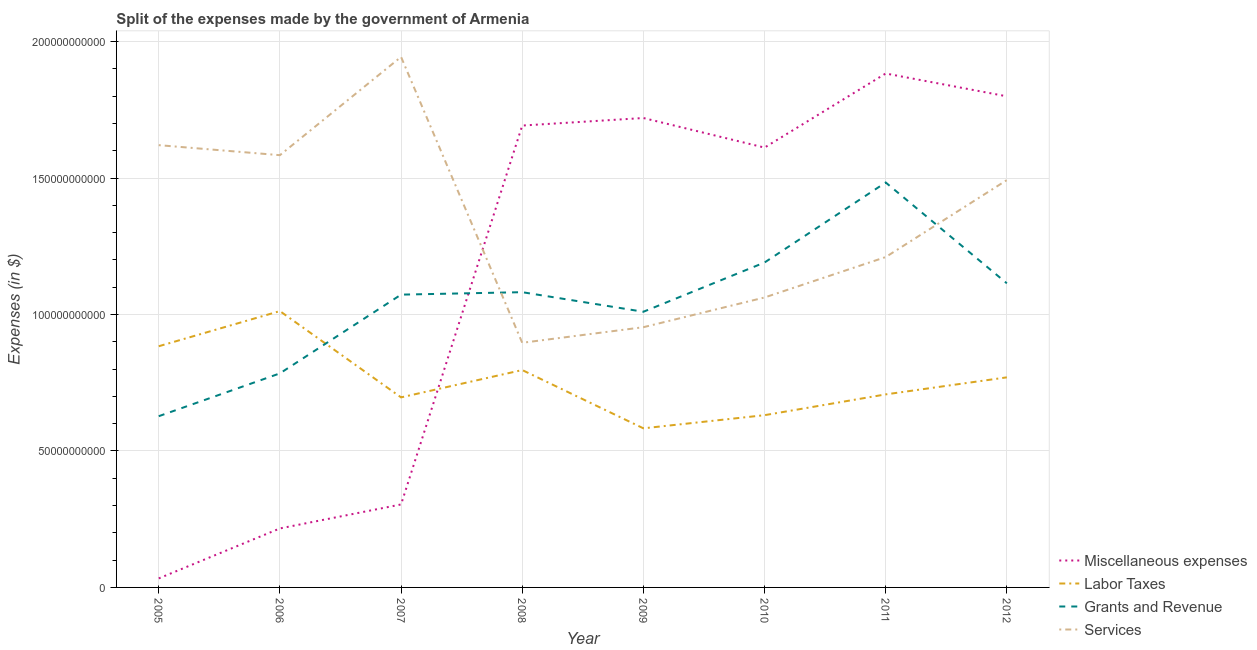How many different coloured lines are there?
Offer a very short reply. 4. Does the line corresponding to amount spent on labor taxes intersect with the line corresponding to amount spent on grants and revenue?
Give a very brief answer. Yes. Is the number of lines equal to the number of legend labels?
Your answer should be very brief. Yes. What is the amount spent on miscellaneous expenses in 2009?
Provide a short and direct response. 1.72e+11. Across all years, what is the maximum amount spent on labor taxes?
Keep it short and to the point. 1.01e+11. Across all years, what is the minimum amount spent on miscellaneous expenses?
Your answer should be very brief. 3.30e+09. In which year was the amount spent on labor taxes maximum?
Provide a succinct answer. 2006. In which year was the amount spent on services minimum?
Give a very brief answer. 2008. What is the total amount spent on services in the graph?
Make the answer very short. 1.08e+12. What is the difference between the amount spent on grants and revenue in 2007 and that in 2009?
Your response must be concise. 6.28e+09. What is the difference between the amount spent on grants and revenue in 2012 and the amount spent on miscellaneous expenses in 2008?
Your response must be concise. -5.78e+1. What is the average amount spent on miscellaneous expenses per year?
Provide a short and direct response. 1.16e+11. In the year 2011, what is the difference between the amount spent on labor taxes and amount spent on services?
Offer a terse response. -5.03e+1. In how many years, is the amount spent on grants and revenue greater than 100000000000 $?
Your response must be concise. 6. What is the ratio of the amount spent on grants and revenue in 2005 to that in 2009?
Ensure brevity in your answer.  0.62. Is the difference between the amount spent on labor taxes in 2008 and 2012 greater than the difference between the amount spent on grants and revenue in 2008 and 2012?
Your answer should be compact. Yes. What is the difference between the highest and the second highest amount spent on labor taxes?
Provide a succinct answer. 1.29e+1. What is the difference between the highest and the lowest amount spent on labor taxes?
Give a very brief answer. 4.30e+1. Is the sum of the amount spent on grants and revenue in 2007 and 2009 greater than the maximum amount spent on labor taxes across all years?
Provide a succinct answer. Yes. Is it the case that in every year, the sum of the amount spent on miscellaneous expenses and amount spent on labor taxes is greater than the sum of amount spent on grants and revenue and amount spent on services?
Provide a succinct answer. No. Is it the case that in every year, the sum of the amount spent on miscellaneous expenses and amount spent on labor taxes is greater than the amount spent on grants and revenue?
Make the answer very short. No. Does the amount spent on labor taxes monotonically increase over the years?
Offer a terse response. No. Is the amount spent on miscellaneous expenses strictly greater than the amount spent on grants and revenue over the years?
Provide a short and direct response. No. How many lines are there?
Your answer should be compact. 4. What is the difference between two consecutive major ticks on the Y-axis?
Give a very brief answer. 5.00e+1. Does the graph contain any zero values?
Offer a terse response. No. Where does the legend appear in the graph?
Provide a succinct answer. Bottom right. How many legend labels are there?
Ensure brevity in your answer.  4. What is the title of the graph?
Your answer should be very brief. Split of the expenses made by the government of Armenia. What is the label or title of the X-axis?
Your answer should be compact. Year. What is the label or title of the Y-axis?
Provide a short and direct response. Expenses (in $). What is the Expenses (in $) of Miscellaneous expenses in 2005?
Your response must be concise. 3.30e+09. What is the Expenses (in $) in Labor Taxes in 2005?
Your answer should be very brief. 8.84e+1. What is the Expenses (in $) of Grants and Revenue in 2005?
Provide a short and direct response. 6.27e+1. What is the Expenses (in $) in Services in 2005?
Your answer should be very brief. 1.62e+11. What is the Expenses (in $) in Miscellaneous expenses in 2006?
Provide a succinct answer. 2.16e+1. What is the Expenses (in $) of Labor Taxes in 2006?
Keep it short and to the point. 1.01e+11. What is the Expenses (in $) of Grants and Revenue in 2006?
Give a very brief answer. 7.84e+1. What is the Expenses (in $) in Services in 2006?
Ensure brevity in your answer.  1.58e+11. What is the Expenses (in $) of Miscellaneous expenses in 2007?
Offer a very short reply. 3.04e+1. What is the Expenses (in $) of Labor Taxes in 2007?
Ensure brevity in your answer.  6.96e+1. What is the Expenses (in $) in Grants and Revenue in 2007?
Give a very brief answer. 1.07e+11. What is the Expenses (in $) of Services in 2007?
Offer a terse response. 1.94e+11. What is the Expenses (in $) in Miscellaneous expenses in 2008?
Offer a very short reply. 1.69e+11. What is the Expenses (in $) of Labor Taxes in 2008?
Give a very brief answer. 7.97e+1. What is the Expenses (in $) in Grants and Revenue in 2008?
Give a very brief answer. 1.08e+11. What is the Expenses (in $) in Services in 2008?
Provide a short and direct response. 8.96e+1. What is the Expenses (in $) in Miscellaneous expenses in 2009?
Provide a succinct answer. 1.72e+11. What is the Expenses (in $) of Labor Taxes in 2009?
Offer a terse response. 5.83e+1. What is the Expenses (in $) of Grants and Revenue in 2009?
Ensure brevity in your answer.  1.01e+11. What is the Expenses (in $) of Services in 2009?
Your answer should be compact. 9.53e+1. What is the Expenses (in $) of Miscellaneous expenses in 2010?
Make the answer very short. 1.61e+11. What is the Expenses (in $) in Labor Taxes in 2010?
Make the answer very short. 6.31e+1. What is the Expenses (in $) in Grants and Revenue in 2010?
Your response must be concise. 1.19e+11. What is the Expenses (in $) of Services in 2010?
Your answer should be compact. 1.06e+11. What is the Expenses (in $) of Miscellaneous expenses in 2011?
Your answer should be very brief. 1.88e+11. What is the Expenses (in $) in Labor Taxes in 2011?
Your answer should be very brief. 7.07e+1. What is the Expenses (in $) of Grants and Revenue in 2011?
Provide a short and direct response. 1.48e+11. What is the Expenses (in $) of Services in 2011?
Ensure brevity in your answer.  1.21e+11. What is the Expenses (in $) of Miscellaneous expenses in 2012?
Keep it short and to the point. 1.80e+11. What is the Expenses (in $) in Labor Taxes in 2012?
Your response must be concise. 7.70e+1. What is the Expenses (in $) of Grants and Revenue in 2012?
Keep it short and to the point. 1.11e+11. What is the Expenses (in $) in Services in 2012?
Provide a short and direct response. 1.49e+11. Across all years, what is the maximum Expenses (in $) of Miscellaneous expenses?
Make the answer very short. 1.88e+11. Across all years, what is the maximum Expenses (in $) of Labor Taxes?
Make the answer very short. 1.01e+11. Across all years, what is the maximum Expenses (in $) of Grants and Revenue?
Provide a succinct answer. 1.48e+11. Across all years, what is the maximum Expenses (in $) of Services?
Keep it short and to the point. 1.94e+11. Across all years, what is the minimum Expenses (in $) of Miscellaneous expenses?
Offer a very short reply. 3.30e+09. Across all years, what is the minimum Expenses (in $) in Labor Taxes?
Keep it short and to the point. 5.83e+1. Across all years, what is the minimum Expenses (in $) of Grants and Revenue?
Give a very brief answer. 6.27e+1. Across all years, what is the minimum Expenses (in $) of Services?
Offer a very short reply. 8.96e+1. What is the total Expenses (in $) of Miscellaneous expenses in the graph?
Provide a short and direct response. 9.26e+11. What is the total Expenses (in $) of Labor Taxes in the graph?
Provide a succinct answer. 6.08e+11. What is the total Expenses (in $) of Grants and Revenue in the graph?
Your answer should be compact. 8.37e+11. What is the total Expenses (in $) in Services in the graph?
Give a very brief answer. 1.08e+12. What is the difference between the Expenses (in $) in Miscellaneous expenses in 2005 and that in 2006?
Offer a terse response. -1.83e+1. What is the difference between the Expenses (in $) in Labor Taxes in 2005 and that in 2006?
Give a very brief answer. -1.29e+1. What is the difference between the Expenses (in $) in Grants and Revenue in 2005 and that in 2006?
Keep it short and to the point. -1.57e+1. What is the difference between the Expenses (in $) of Services in 2005 and that in 2006?
Keep it short and to the point. 3.67e+09. What is the difference between the Expenses (in $) in Miscellaneous expenses in 2005 and that in 2007?
Your answer should be compact. -2.71e+1. What is the difference between the Expenses (in $) of Labor Taxes in 2005 and that in 2007?
Give a very brief answer. 1.87e+1. What is the difference between the Expenses (in $) in Grants and Revenue in 2005 and that in 2007?
Give a very brief answer. -4.45e+1. What is the difference between the Expenses (in $) of Services in 2005 and that in 2007?
Keep it short and to the point. -3.23e+1. What is the difference between the Expenses (in $) in Miscellaneous expenses in 2005 and that in 2008?
Provide a succinct answer. -1.66e+11. What is the difference between the Expenses (in $) in Labor Taxes in 2005 and that in 2008?
Your answer should be very brief. 8.72e+09. What is the difference between the Expenses (in $) of Grants and Revenue in 2005 and that in 2008?
Keep it short and to the point. -4.54e+1. What is the difference between the Expenses (in $) of Services in 2005 and that in 2008?
Provide a short and direct response. 7.24e+1. What is the difference between the Expenses (in $) in Miscellaneous expenses in 2005 and that in 2009?
Offer a very short reply. -1.69e+11. What is the difference between the Expenses (in $) in Labor Taxes in 2005 and that in 2009?
Give a very brief answer. 3.01e+1. What is the difference between the Expenses (in $) in Grants and Revenue in 2005 and that in 2009?
Provide a succinct answer. -3.83e+1. What is the difference between the Expenses (in $) of Services in 2005 and that in 2009?
Offer a terse response. 6.67e+1. What is the difference between the Expenses (in $) of Miscellaneous expenses in 2005 and that in 2010?
Offer a terse response. -1.58e+11. What is the difference between the Expenses (in $) of Labor Taxes in 2005 and that in 2010?
Give a very brief answer. 2.53e+1. What is the difference between the Expenses (in $) of Grants and Revenue in 2005 and that in 2010?
Give a very brief answer. -5.63e+1. What is the difference between the Expenses (in $) in Services in 2005 and that in 2010?
Provide a short and direct response. 5.58e+1. What is the difference between the Expenses (in $) of Miscellaneous expenses in 2005 and that in 2011?
Provide a short and direct response. -1.85e+11. What is the difference between the Expenses (in $) of Labor Taxes in 2005 and that in 2011?
Keep it short and to the point. 1.76e+1. What is the difference between the Expenses (in $) of Grants and Revenue in 2005 and that in 2011?
Ensure brevity in your answer.  -8.56e+1. What is the difference between the Expenses (in $) in Services in 2005 and that in 2011?
Offer a terse response. 4.10e+1. What is the difference between the Expenses (in $) of Miscellaneous expenses in 2005 and that in 2012?
Provide a succinct answer. -1.77e+11. What is the difference between the Expenses (in $) of Labor Taxes in 2005 and that in 2012?
Give a very brief answer. 1.14e+1. What is the difference between the Expenses (in $) in Grants and Revenue in 2005 and that in 2012?
Make the answer very short. -4.87e+1. What is the difference between the Expenses (in $) in Services in 2005 and that in 2012?
Give a very brief answer. 1.28e+1. What is the difference between the Expenses (in $) of Miscellaneous expenses in 2006 and that in 2007?
Your answer should be very brief. -8.79e+09. What is the difference between the Expenses (in $) in Labor Taxes in 2006 and that in 2007?
Provide a short and direct response. 3.16e+1. What is the difference between the Expenses (in $) in Grants and Revenue in 2006 and that in 2007?
Keep it short and to the point. -2.89e+1. What is the difference between the Expenses (in $) of Services in 2006 and that in 2007?
Keep it short and to the point. -3.60e+1. What is the difference between the Expenses (in $) in Miscellaneous expenses in 2006 and that in 2008?
Your answer should be very brief. -1.48e+11. What is the difference between the Expenses (in $) of Labor Taxes in 2006 and that in 2008?
Keep it short and to the point. 2.16e+1. What is the difference between the Expenses (in $) in Grants and Revenue in 2006 and that in 2008?
Keep it short and to the point. -2.98e+1. What is the difference between the Expenses (in $) of Services in 2006 and that in 2008?
Your answer should be very brief. 6.87e+1. What is the difference between the Expenses (in $) of Miscellaneous expenses in 2006 and that in 2009?
Keep it short and to the point. -1.50e+11. What is the difference between the Expenses (in $) of Labor Taxes in 2006 and that in 2009?
Offer a terse response. 4.30e+1. What is the difference between the Expenses (in $) in Grants and Revenue in 2006 and that in 2009?
Keep it short and to the point. -2.26e+1. What is the difference between the Expenses (in $) of Services in 2006 and that in 2009?
Your answer should be compact. 6.30e+1. What is the difference between the Expenses (in $) of Miscellaneous expenses in 2006 and that in 2010?
Give a very brief answer. -1.40e+11. What is the difference between the Expenses (in $) in Labor Taxes in 2006 and that in 2010?
Provide a succinct answer. 3.81e+1. What is the difference between the Expenses (in $) of Grants and Revenue in 2006 and that in 2010?
Keep it short and to the point. -4.06e+1. What is the difference between the Expenses (in $) in Services in 2006 and that in 2010?
Your answer should be compact. 5.21e+1. What is the difference between the Expenses (in $) in Miscellaneous expenses in 2006 and that in 2011?
Your answer should be very brief. -1.67e+11. What is the difference between the Expenses (in $) of Labor Taxes in 2006 and that in 2011?
Give a very brief answer. 3.05e+1. What is the difference between the Expenses (in $) of Grants and Revenue in 2006 and that in 2011?
Your answer should be compact. -6.99e+1. What is the difference between the Expenses (in $) of Services in 2006 and that in 2011?
Offer a very short reply. 3.73e+1. What is the difference between the Expenses (in $) in Miscellaneous expenses in 2006 and that in 2012?
Your response must be concise. -1.58e+11. What is the difference between the Expenses (in $) of Labor Taxes in 2006 and that in 2012?
Offer a very short reply. 2.43e+1. What is the difference between the Expenses (in $) in Grants and Revenue in 2006 and that in 2012?
Give a very brief answer. -3.30e+1. What is the difference between the Expenses (in $) in Services in 2006 and that in 2012?
Keep it short and to the point. 9.12e+09. What is the difference between the Expenses (in $) of Miscellaneous expenses in 2007 and that in 2008?
Give a very brief answer. -1.39e+11. What is the difference between the Expenses (in $) of Labor Taxes in 2007 and that in 2008?
Ensure brevity in your answer.  -1.00e+1. What is the difference between the Expenses (in $) in Grants and Revenue in 2007 and that in 2008?
Provide a short and direct response. -8.98e+08. What is the difference between the Expenses (in $) of Services in 2007 and that in 2008?
Your response must be concise. 1.05e+11. What is the difference between the Expenses (in $) in Miscellaneous expenses in 2007 and that in 2009?
Offer a very short reply. -1.42e+11. What is the difference between the Expenses (in $) of Labor Taxes in 2007 and that in 2009?
Ensure brevity in your answer.  1.13e+1. What is the difference between the Expenses (in $) of Grants and Revenue in 2007 and that in 2009?
Give a very brief answer. 6.28e+09. What is the difference between the Expenses (in $) of Services in 2007 and that in 2009?
Provide a succinct answer. 9.90e+1. What is the difference between the Expenses (in $) of Miscellaneous expenses in 2007 and that in 2010?
Offer a terse response. -1.31e+11. What is the difference between the Expenses (in $) of Labor Taxes in 2007 and that in 2010?
Provide a succinct answer. 6.53e+09. What is the difference between the Expenses (in $) of Grants and Revenue in 2007 and that in 2010?
Keep it short and to the point. -1.18e+1. What is the difference between the Expenses (in $) in Services in 2007 and that in 2010?
Keep it short and to the point. 8.82e+1. What is the difference between the Expenses (in $) in Miscellaneous expenses in 2007 and that in 2011?
Your response must be concise. -1.58e+11. What is the difference between the Expenses (in $) in Labor Taxes in 2007 and that in 2011?
Offer a terse response. -1.09e+09. What is the difference between the Expenses (in $) of Grants and Revenue in 2007 and that in 2011?
Give a very brief answer. -4.11e+1. What is the difference between the Expenses (in $) of Services in 2007 and that in 2011?
Provide a short and direct response. 7.33e+1. What is the difference between the Expenses (in $) in Miscellaneous expenses in 2007 and that in 2012?
Give a very brief answer. -1.50e+11. What is the difference between the Expenses (in $) of Labor Taxes in 2007 and that in 2012?
Ensure brevity in your answer.  -7.34e+09. What is the difference between the Expenses (in $) of Grants and Revenue in 2007 and that in 2012?
Your answer should be compact. -4.14e+09. What is the difference between the Expenses (in $) of Services in 2007 and that in 2012?
Offer a terse response. 4.51e+1. What is the difference between the Expenses (in $) of Miscellaneous expenses in 2008 and that in 2009?
Keep it short and to the point. -2.76e+09. What is the difference between the Expenses (in $) in Labor Taxes in 2008 and that in 2009?
Ensure brevity in your answer.  2.14e+1. What is the difference between the Expenses (in $) of Grants and Revenue in 2008 and that in 2009?
Your answer should be very brief. 7.18e+09. What is the difference between the Expenses (in $) in Services in 2008 and that in 2009?
Offer a very short reply. -5.71e+09. What is the difference between the Expenses (in $) of Miscellaneous expenses in 2008 and that in 2010?
Your answer should be compact. 8.07e+09. What is the difference between the Expenses (in $) in Labor Taxes in 2008 and that in 2010?
Keep it short and to the point. 1.65e+1. What is the difference between the Expenses (in $) in Grants and Revenue in 2008 and that in 2010?
Your answer should be compact. -1.09e+1. What is the difference between the Expenses (in $) of Services in 2008 and that in 2010?
Offer a terse response. -1.66e+1. What is the difference between the Expenses (in $) of Miscellaneous expenses in 2008 and that in 2011?
Make the answer very short. -1.91e+1. What is the difference between the Expenses (in $) of Labor Taxes in 2008 and that in 2011?
Offer a very short reply. 8.92e+09. What is the difference between the Expenses (in $) in Grants and Revenue in 2008 and that in 2011?
Your answer should be compact. -4.02e+1. What is the difference between the Expenses (in $) of Services in 2008 and that in 2011?
Give a very brief answer. -3.14e+1. What is the difference between the Expenses (in $) in Miscellaneous expenses in 2008 and that in 2012?
Provide a short and direct response. -1.07e+1. What is the difference between the Expenses (in $) in Labor Taxes in 2008 and that in 2012?
Offer a very short reply. 2.67e+09. What is the difference between the Expenses (in $) in Grants and Revenue in 2008 and that in 2012?
Your answer should be compact. -3.24e+09. What is the difference between the Expenses (in $) in Services in 2008 and that in 2012?
Provide a short and direct response. -5.96e+1. What is the difference between the Expenses (in $) in Miscellaneous expenses in 2009 and that in 2010?
Make the answer very short. 1.08e+1. What is the difference between the Expenses (in $) of Labor Taxes in 2009 and that in 2010?
Your response must be concise. -4.82e+09. What is the difference between the Expenses (in $) of Grants and Revenue in 2009 and that in 2010?
Offer a very short reply. -1.80e+1. What is the difference between the Expenses (in $) in Services in 2009 and that in 2010?
Provide a succinct answer. -1.09e+1. What is the difference between the Expenses (in $) in Miscellaneous expenses in 2009 and that in 2011?
Your response must be concise. -1.63e+1. What is the difference between the Expenses (in $) of Labor Taxes in 2009 and that in 2011?
Give a very brief answer. -1.24e+1. What is the difference between the Expenses (in $) of Grants and Revenue in 2009 and that in 2011?
Offer a terse response. -4.74e+1. What is the difference between the Expenses (in $) of Services in 2009 and that in 2011?
Provide a succinct answer. -2.57e+1. What is the difference between the Expenses (in $) of Miscellaneous expenses in 2009 and that in 2012?
Your response must be concise. -7.95e+09. What is the difference between the Expenses (in $) in Labor Taxes in 2009 and that in 2012?
Your answer should be compact. -1.87e+1. What is the difference between the Expenses (in $) in Grants and Revenue in 2009 and that in 2012?
Ensure brevity in your answer.  -1.04e+1. What is the difference between the Expenses (in $) in Services in 2009 and that in 2012?
Give a very brief answer. -5.39e+1. What is the difference between the Expenses (in $) in Miscellaneous expenses in 2010 and that in 2011?
Provide a succinct answer. -2.71e+1. What is the difference between the Expenses (in $) of Labor Taxes in 2010 and that in 2011?
Offer a terse response. -7.62e+09. What is the difference between the Expenses (in $) of Grants and Revenue in 2010 and that in 2011?
Offer a very short reply. -2.93e+1. What is the difference between the Expenses (in $) of Services in 2010 and that in 2011?
Keep it short and to the point. -1.48e+1. What is the difference between the Expenses (in $) of Miscellaneous expenses in 2010 and that in 2012?
Your answer should be compact. -1.88e+1. What is the difference between the Expenses (in $) of Labor Taxes in 2010 and that in 2012?
Your response must be concise. -1.39e+1. What is the difference between the Expenses (in $) in Grants and Revenue in 2010 and that in 2012?
Ensure brevity in your answer.  7.63e+09. What is the difference between the Expenses (in $) in Services in 2010 and that in 2012?
Give a very brief answer. -4.30e+1. What is the difference between the Expenses (in $) in Miscellaneous expenses in 2011 and that in 2012?
Your answer should be compact. 8.36e+09. What is the difference between the Expenses (in $) of Labor Taxes in 2011 and that in 2012?
Your answer should be very brief. -6.24e+09. What is the difference between the Expenses (in $) in Grants and Revenue in 2011 and that in 2012?
Give a very brief answer. 3.69e+1. What is the difference between the Expenses (in $) in Services in 2011 and that in 2012?
Offer a very short reply. -2.82e+1. What is the difference between the Expenses (in $) in Miscellaneous expenses in 2005 and the Expenses (in $) in Labor Taxes in 2006?
Your answer should be very brief. -9.79e+1. What is the difference between the Expenses (in $) of Miscellaneous expenses in 2005 and the Expenses (in $) of Grants and Revenue in 2006?
Ensure brevity in your answer.  -7.51e+1. What is the difference between the Expenses (in $) of Miscellaneous expenses in 2005 and the Expenses (in $) of Services in 2006?
Your answer should be very brief. -1.55e+11. What is the difference between the Expenses (in $) of Labor Taxes in 2005 and the Expenses (in $) of Grants and Revenue in 2006?
Make the answer very short. 9.94e+09. What is the difference between the Expenses (in $) in Labor Taxes in 2005 and the Expenses (in $) in Services in 2006?
Keep it short and to the point. -7.00e+1. What is the difference between the Expenses (in $) of Grants and Revenue in 2005 and the Expenses (in $) of Services in 2006?
Keep it short and to the point. -9.56e+1. What is the difference between the Expenses (in $) in Miscellaneous expenses in 2005 and the Expenses (in $) in Labor Taxes in 2007?
Ensure brevity in your answer.  -6.63e+1. What is the difference between the Expenses (in $) of Miscellaneous expenses in 2005 and the Expenses (in $) of Grants and Revenue in 2007?
Provide a succinct answer. -1.04e+11. What is the difference between the Expenses (in $) of Miscellaneous expenses in 2005 and the Expenses (in $) of Services in 2007?
Give a very brief answer. -1.91e+11. What is the difference between the Expenses (in $) in Labor Taxes in 2005 and the Expenses (in $) in Grants and Revenue in 2007?
Offer a very short reply. -1.89e+1. What is the difference between the Expenses (in $) of Labor Taxes in 2005 and the Expenses (in $) of Services in 2007?
Offer a very short reply. -1.06e+11. What is the difference between the Expenses (in $) in Grants and Revenue in 2005 and the Expenses (in $) in Services in 2007?
Your answer should be compact. -1.32e+11. What is the difference between the Expenses (in $) in Miscellaneous expenses in 2005 and the Expenses (in $) in Labor Taxes in 2008?
Your response must be concise. -7.63e+1. What is the difference between the Expenses (in $) in Miscellaneous expenses in 2005 and the Expenses (in $) in Grants and Revenue in 2008?
Your answer should be compact. -1.05e+11. What is the difference between the Expenses (in $) of Miscellaneous expenses in 2005 and the Expenses (in $) of Services in 2008?
Keep it short and to the point. -8.63e+1. What is the difference between the Expenses (in $) in Labor Taxes in 2005 and the Expenses (in $) in Grants and Revenue in 2008?
Provide a short and direct response. -1.98e+1. What is the difference between the Expenses (in $) of Labor Taxes in 2005 and the Expenses (in $) of Services in 2008?
Provide a succinct answer. -1.27e+09. What is the difference between the Expenses (in $) of Grants and Revenue in 2005 and the Expenses (in $) of Services in 2008?
Your answer should be compact. -2.69e+1. What is the difference between the Expenses (in $) in Miscellaneous expenses in 2005 and the Expenses (in $) in Labor Taxes in 2009?
Your answer should be very brief. -5.50e+1. What is the difference between the Expenses (in $) of Miscellaneous expenses in 2005 and the Expenses (in $) of Grants and Revenue in 2009?
Offer a terse response. -9.77e+1. What is the difference between the Expenses (in $) of Miscellaneous expenses in 2005 and the Expenses (in $) of Services in 2009?
Offer a very short reply. -9.20e+1. What is the difference between the Expenses (in $) in Labor Taxes in 2005 and the Expenses (in $) in Grants and Revenue in 2009?
Your answer should be very brief. -1.26e+1. What is the difference between the Expenses (in $) of Labor Taxes in 2005 and the Expenses (in $) of Services in 2009?
Your answer should be compact. -6.98e+09. What is the difference between the Expenses (in $) of Grants and Revenue in 2005 and the Expenses (in $) of Services in 2009?
Offer a very short reply. -3.26e+1. What is the difference between the Expenses (in $) in Miscellaneous expenses in 2005 and the Expenses (in $) in Labor Taxes in 2010?
Provide a short and direct response. -5.98e+1. What is the difference between the Expenses (in $) of Miscellaneous expenses in 2005 and the Expenses (in $) of Grants and Revenue in 2010?
Offer a terse response. -1.16e+11. What is the difference between the Expenses (in $) of Miscellaneous expenses in 2005 and the Expenses (in $) of Services in 2010?
Provide a succinct answer. -1.03e+11. What is the difference between the Expenses (in $) in Labor Taxes in 2005 and the Expenses (in $) in Grants and Revenue in 2010?
Provide a short and direct response. -3.07e+1. What is the difference between the Expenses (in $) in Labor Taxes in 2005 and the Expenses (in $) in Services in 2010?
Give a very brief answer. -1.79e+1. What is the difference between the Expenses (in $) in Grants and Revenue in 2005 and the Expenses (in $) in Services in 2010?
Your answer should be compact. -4.35e+1. What is the difference between the Expenses (in $) in Miscellaneous expenses in 2005 and the Expenses (in $) in Labor Taxes in 2011?
Make the answer very short. -6.74e+1. What is the difference between the Expenses (in $) in Miscellaneous expenses in 2005 and the Expenses (in $) in Grants and Revenue in 2011?
Provide a succinct answer. -1.45e+11. What is the difference between the Expenses (in $) in Miscellaneous expenses in 2005 and the Expenses (in $) in Services in 2011?
Provide a short and direct response. -1.18e+11. What is the difference between the Expenses (in $) in Labor Taxes in 2005 and the Expenses (in $) in Grants and Revenue in 2011?
Give a very brief answer. -6.00e+1. What is the difference between the Expenses (in $) in Labor Taxes in 2005 and the Expenses (in $) in Services in 2011?
Your response must be concise. -3.27e+1. What is the difference between the Expenses (in $) in Grants and Revenue in 2005 and the Expenses (in $) in Services in 2011?
Keep it short and to the point. -5.83e+1. What is the difference between the Expenses (in $) in Miscellaneous expenses in 2005 and the Expenses (in $) in Labor Taxes in 2012?
Provide a short and direct response. -7.37e+1. What is the difference between the Expenses (in $) in Miscellaneous expenses in 2005 and the Expenses (in $) in Grants and Revenue in 2012?
Your answer should be compact. -1.08e+11. What is the difference between the Expenses (in $) of Miscellaneous expenses in 2005 and the Expenses (in $) of Services in 2012?
Offer a very short reply. -1.46e+11. What is the difference between the Expenses (in $) of Labor Taxes in 2005 and the Expenses (in $) of Grants and Revenue in 2012?
Ensure brevity in your answer.  -2.31e+1. What is the difference between the Expenses (in $) in Labor Taxes in 2005 and the Expenses (in $) in Services in 2012?
Offer a very short reply. -6.09e+1. What is the difference between the Expenses (in $) of Grants and Revenue in 2005 and the Expenses (in $) of Services in 2012?
Offer a very short reply. -8.65e+1. What is the difference between the Expenses (in $) of Miscellaneous expenses in 2006 and the Expenses (in $) of Labor Taxes in 2007?
Your answer should be compact. -4.80e+1. What is the difference between the Expenses (in $) in Miscellaneous expenses in 2006 and the Expenses (in $) in Grants and Revenue in 2007?
Your answer should be compact. -8.57e+1. What is the difference between the Expenses (in $) in Miscellaneous expenses in 2006 and the Expenses (in $) in Services in 2007?
Provide a short and direct response. -1.73e+11. What is the difference between the Expenses (in $) of Labor Taxes in 2006 and the Expenses (in $) of Grants and Revenue in 2007?
Offer a terse response. -6.03e+09. What is the difference between the Expenses (in $) in Labor Taxes in 2006 and the Expenses (in $) in Services in 2007?
Your answer should be very brief. -9.31e+1. What is the difference between the Expenses (in $) of Grants and Revenue in 2006 and the Expenses (in $) of Services in 2007?
Keep it short and to the point. -1.16e+11. What is the difference between the Expenses (in $) in Miscellaneous expenses in 2006 and the Expenses (in $) in Labor Taxes in 2008?
Provide a short and direct response. -5.80e+1. What is the difference between the Expenses (in $) in Miscellaneous expenses in 2006 and the Expenses (in $) in Grants and Revenue in 2008?
Make the answer very short. -8.66e+1. What is the difference between the Expenses (in $) of Miscellaneous expenses in 2006 and the Expenses (in $) of Services in 2008?
Give a very brief answer. -6.80e+1. What is the difference between the Expenses (in $) in Labor Taxes in 2006 and the Expenses (in $) in Grants and Revenue in 2008?
Your response must be concise. -6.93e+09. What is the difference between the Expenses (in $) of Labor Taxes in 2006 and the Expenses (in $) of Services in 2008?
Your response must be concise. 1.16e+1. What is the difference between the Expenses (in $) in Grants and Revenue in 2006 and the Expenses (in $) in Services in 2008?
Your answer should be compact. -1.12e+1. What is the difference between the Expenses (in $) of Miscellaneous expenses in 2006 and the Expenses (in $) of Labor Taxes in 2009?
Offer a very short reply. -3.67e+1. What is the difference between the Expenses (in $) of Miscellaneous expenses in 2006 and the Expenses (in $) of Grants and Revenue in 2009?
Keep it short and to the point. -7.94e+1. What is the difference between the Expenses (in $) in Miscellaneous expenses in 2006 and the Expenses (in $) in Services in 2009?
Your answer should be compact. -7.37e+1. What is the difference between the Expenses (in $) of Labor Taxes in 2006 and the Expenses (in $) of Grants and Revenue in 2009?
Give a very brief answer. 2.45e+08. What is the difference between the Expenses (in $) in Labor Taxes in 2006 and the Expenses (in $) in Services in 2009?
Keep it short and to the point. 5.90e+09. What is the difference between the Expenses (in $) in Grants and Revenue in 2006 and the Expenses (in $) in Services in 2009?
Ensure brevity in your answer.  -1.69e+1. What is the difference between the Expenses (in $) in Miscellaneous expenses in 2006 and the Expenses (in $) in Labor Taxes in 2010?
Give a very brief answer. -4.15e+1. What is the difference between the Expenses (in $) of Miscellaneous expenses in 2006 and the Expenses (in $) of Grants and Revenue in 2010?
Make the answer very short. -9.74e+1. What is the difference between the Expenses (in $) in Miscellaneous expenses in 2006 and the Expenses (in $) in Services in 2010?
Your response must be concise. -8.46e+1. What is the difference between the Expenses (in $) of Labor Taxes in 2006 and the Expenses (in $) of Grants and Revenue in 2010?
Provide a succinct answer. -1.78e+1. What is the difference between the Expenses (in $) of Labor Taxes in 2006 and the Expenses (in $) of Services in 2010?
Provide a short and direct response. -4.99e+09. What is the difference between the Expenses (in $) of Grants and Revenue in 2006 and the Expenses (in $) of Services in 2010?
Make the answer very short. -2.78e+1. What is the difference between the Expenses (in $) of Miscellaneous expenses in 2006 and the Expenses (in $) of Labor Taxes in 2011?
Offer a very short reply. -4.91e+1. What is the difference between the Expenses (in $) in Miscellaneous expenses in 2006 and the Expenses (in $) in Grants and Revenue in 2011?
Your answer should be very brief. -1.27e+11. What is the difference between the Expenses (in $) of Miscellaneous expenses in 2006 and the Expenses (in $) of Services in 2011?
Give a very brief answer. -9.94e+1. What is the difference between the Expenses (in $) of Labor Taxes in 2006 and the Expenses (in $) of Grants and Revenue in 2011?
Your answer should be compact. -4.71e+1. What is the difference between the Expenses (in $) of Labor Taxes in 2006 and the Expenses (in $) of Services in 2011?
Offer a very short reply. -1.98e+1. What is the difference between the Expenses (in $) of Grants and Revenue in 2006 and the Expenses (in $) of Services in 2011?
Offer a very short reply. -4.26e+1. What is the difference between the Expenses (in $) of Miscellaneous expenses in 2006 and the Expenses (in $) of Labor Taxes in 2012?
Ensure brevity in your answer.  -5.54e+1. What is the difference between the Expenses (in $) of Miscellaneous expenses in 2006 and the Expenses (in $) of Grants and Revenue in 2012?
Provide a succinct answer. -8.98e+1. What is the difference between the Expenses (in $) in Miscellaneous expenses in 2006 and the Expenses (in $) in Services in 2012?
Your response must be concise. -1.28e+11. What is the difference between the Expenses (in $) in Labor Taxes in 2006 and the Expenses (in $) in Grants and Revenue in 2012?
Keep it short and to the point. -1.02e+1. What is the difference between the Expenses (in $) of Labor Taxes in 2006 and the Expenses (in $) of Services in 2012?
Offer a terse response. -4.80e+1. What is the difference between the Expenses (in $) in Grants and Revenue in 2006 and the Expenses (in $) in Services in 2012?
Offer a very short reply. -7.08e+1. What is the difference between the Expenses (in $) in Miscellaneous expenses in 2007 and the Expenses (in $) in Labor Taxes in 2008?
Your response must be concise. -4.92e+1. What is the difference between the Expenses (in $) of Miscellaneous expenses in 2007 and the Expenses (in $) of Grants and Revenue in 2008?
Offer a very short reply. -7.78e+1. What is the difference between the Expenses (in $) in Miscellaneous expenses in 2007 and the Expenses (in $) in Services in 2008?
Make the answer very short. -5.92e+1. What is the difference between the Expenses (in $) of Labor Taxes in 2007 and the Expenses (in $) of Grants and Revenue in 2008?
Keep it short and to the point. -3.85e+1. What is the difference between the Expenses (in $) of Labor Taxes in 2007 and the Expenses (in $) of Services in 2008?
Offer a terse response. -2.00e+1. What is the difference between the Expenses (in $) in Grants and Revenue in 2007 and the Expenses (in $) in Services in 2008?
Your response must be concise. 1.76e+1. What is the difference between the Expenses (in $) in Miscellaneous expenses in 2007 and the Expenses (in $) in Labor Taxes in 2009?
Make the answer very short. -2.79e+1. What is the difference between the Expenses (in $) of Miscellaneous expenses in 2007 and the Expenses (in $) of Grants and Revenue in 2009?
Give a very brief answer. -7.06e+1. What is the difference between the Expenses (in $) in Miscellaneous expenses in 2007 and the Expenses (in $) in Services in 2009?
Offer a terse response. -6.49e+1. What is the difference between the Expenses (in $) of Labor Taxes in 2007 and the Expenses (in $) of Grants and Revenue in 2009?
Your answer should be very brief. -3.14e+1. What is the difference between the Expenses (in $) in Labor Taxes in 2007 and the Expenses (in $) in Services in 2009?
Your response must be concise. -2.57e+1. What is the difference between the Expenses (in $) in Grants and Revenue in 2007 and the Expenses (in $) in Services in 2009?
Provide a succinct answer. 1.19e+1. What is the difference between the Expenses (in $) in Miscellaneous expenses in 2007 and the Expenses (in $) in Labor Taxes in 2010?
Your response must be concise. -3.27e+1. What is the difference between the Expenses (in $) of Miscellaneous expenses in 2007 and the Expenses (in $) of Grants and Revenue in 2010?
Keep it short and to the point. -8.87e+1. What is the difference between the Expenses (in $) in Miscellaneous expenses in 2007 and the Expenses (in $) in Services in 2010?
Provide a succinct answer. -7.58e+1. What is the difference between the Expenses (in $) in Labor Taxes in 2007 and the Expenses (in $) in Grants and Revenue in 2010?
Your response must be concise. -4.94e+1. What is the difference between the Expenses (in $) of Labor Taxes in 2007 and the Expenses (in $) of Services in 2010?
Ensure brevity in your answer.  -3.66e+1. What is the difference between the Expenses (in $) in Grants and Revenue in 2007 and the Expenses (in $) in Services in 2010?
Give a very brief answer. 1.05e+09. What is the difference between the Expenses (in $) of Miscellaneous expenses in 2007 and the Expenses (in $) of Labor Taxes in 2011?
Make the answer very short. -4.03e+1. What is the difference between the Expenses (in $) of Miscellaneous expenses in 2007 and the Expenses (in $) of Grants and Revenue in 2011?
Give a very brief answer. -1.18e+11. What is the difference between the Expenses (in $) of Miscellaneous expenses in 2007 and the Expenses (in $) of Services in 2011?
Provide a succinct answer. -9.06e+1. What is the difference between the Expenses (in $) of Labor Taxes in 2007 and the Expenses (in $) of Grants and Revenue in 2011?
Ensure brevity in your answer.  -7.87e+1. What is the difference between the Expenses (in $) of Labor Taxes in 2007 and the Expenses (in $) of Services in 2011?
Ensure brevity in your answer.  -5.14e+1. What is the difference between the Expenses (in $) in Grants and Revenue in 2007 and the Expenses (in $) in Services in 2011?
Give a very brief answer. -1.38e+1. What is the difference between the Expenses (in $) of Miscellaneous expenses in 2007 and the Expenses (in $) of Labor Taxes in 2012?
Your answer should be very brief. -4.66e+1. What is the difference between the Expenses (in $) of Miscellaneous expenses in 2007 and the Expenses (in $) of Grants and Revenue in 2012?
Offer a terse response. -8.10e+1. What is the difference between the Expenses (in $) of Miscellaneous expenses in 2007 and the Expenses (in $) of Services in 2012?
Keep it short and to the point. -1.19e+11. What is the difference between the Expenses (in $) of Labor Taxes in 2007 and the Expenses (in $) of Grants and Revenue in 2012?
Your response must be concise. -4.18e+1. What is the difference between the Expenses (in $) in Labor Taxes in 2007 and the Expenses (in $) in Services in 2012?
Offer a very short reply. -7.96e+1. What is the difference between the Expenses (in $) of Grants and Revenue in 2007 and the Expenses (in $) of Services in 2012?
Offer a very short reply. -4.20e+1. What is the difference between the Expenses (in $) in Miscellaneous expenses in 2008 and the Expenses (in $) in Labor Taxes in 2009?
Your response must be concise. 1.11e+11. What is the difference between the Expenses (in $) of Miscellaneous expenses in 2008 and the Expenses (in $) of Grants and Revenue in 2009?
Keep it short and to the point. 6.82e+1. What is the difference between the Expenses (in $) in Miscellaneous expenses in 2008 and the Expenses (in $) in Services in 2009?
Provide a short and direct response. 7.39e+1. What is the difference between the Expenses (in $) in Labor Taxes in 2008 and the Expenses (in $) in Grants and Revenue in 2009?
Offer a terse response. -2.14e+1. What is the difference between the Expenses (in $) in Labor Taxes in 2008 and the Expenses (in $) in Services in 2009?
Provide a short and direct response. -1.57e+1. What is the difference between the Expenses (in $) of Grants and Revenue in 2008 and the Expenses (in $) of Services in 2009?
Provide a succinct answer. 1.28e+1. What is the difference between the Expenses (in $) of Miscellaneous expenses in 2008 and the Expenses (in $) of Labor Taxes in 2010?
Your response must be concise. 1.06e+11. What is the difference between the Expenses (in $) of Miscellaneous expenses in 2008 and the Expenses (in $) of Grants and Revenue in 2010?
Provide a short and direct response. 5.02e+1. What is the difference between the Expenses (in $) in Miscellaneous expenses in 2008 and the Expenses (in $) in Services in 2010?
Provide a succinct answer. 6.30e+1. What is the difference between the Expenses (in $) in Labor Taxes in 2008 and the Expenses (in $) in Grants and Revenue in 2010?
Offer a terse response. -3.94e+1. What is the difference between the Expenses (in $) of Labor Taxes in 2008 and the Expenses (in $) of Services in 2010?
Make the answer very short. -2.66e+1. What is the difference between the Expenses (in $) of Grants and Revenue in 2008 and the Expenses (in $) of Services in 2010?
Your answer should be very brief. 1.94e+09. What is the difference between the Expenses (in $) of Miscellaneous expenses in 2008 and the Expenses (in $) of Labor Taxes in 2011?
Keep it short and to the point. 9.85e+1. What is the difference between the Expenses (in $) in Miscellaneous expenses in 2008 and the Expenses (in $) in Grants and Revenue in 2011?
Your response must be concise. 2.09e+1. What is the difference between the Expenses (in $) of Miscellaneous expenses in 2008 and the Expenses (in $) of Services in 2011?
Your answer should be very brief. 4.82e+1. What is the difference between the Expenses (in $) of Labor Taxes in 2008 and the Expenses (in $) of Grants and Revenue in 2011?
Provide a short and direct response. -6.87e+1. What is the difference between the Expenses (in $) in Labor Taxes in 2008 and the Expenses (in $) in Services in 2011?
Ensure brevity in your answer.  -4.14e+1. What is the difference between the Expenses (in $) of Grants and Revenue in 2008 and the Expenses (in $) of Services in 2011?
Your answer should be very brief. -1.29e+1. What is the difference between the Expenses (in $) of Miscellaneous expenses in 2008 and the Expenses (in $) of Labor Taxes in 2012?
Ensure brevity in your answer.  9.23e+1. What is the difference between the Expenses (in $) of Miscellaneous expenses in 2008 and the Expenses (in $) of Grants and Revenue in 2012?
Provide a succinct answer. 5.78e+1. What is the difference between the Expenses (in $) in Miscellaneous expenses in 2008 and the Expenses (in $) in Services in 2012?
Make the answer very short. 2.00e+1. What is the difference between the Expenses (in $) in Labor Taxes in 2008 and the Expenses (in $) in Grants and Revenue in 2012?
Keep it short and to the point. -3.18e+1. What is the difference between the Expenses (in $) in Labor Taxes in 2008 and the Expenses (in $) in Services in 2012?
Keep it short and to the point. -6.96e+1. What is the difference between the Expenses (in $) of Grants and Revenue in 2008 and the Expenses (in $) of Services in 2012?
Ensure brevity in your answer.  -4.11e+1. What is the difference between the Expenses (in $) in Miscellaneous expenses in 2009 and the Expenses (in $) in Labor Taxes in 2010?
Offer a very short reply. 1.09e+11. What is the difference between the Expenses (in $) of Miscellaneous expenses in 2009 and the Expenses (in $) of Grants and Revenue in 2010?
Keep it short and to the point. 5.29e+1. What is the difference between the Expenses (in $) of Miscellaneous expenses in 2009 and the Expenses (in $) of Services in 2010?
Give a very brief answer. 6.58e+1. What is the difference between the Expenses (in $) in Labor Taxes in 2009 and the Expenses (in $) in Grants and Revenue in 2010?
Your answer should be compact. -6.08e+1. What is the difference between the Expenses (in $) of Labor Taxes in 2009 and the Expenses (in $) of Services in 2010?
Give a very brief answer. -4.79e+1. What is the difference between the Expenses (in $) in Grants and Revenue in 2009 and the Expenses (in $) in Services in 2010?
Your response must be concise. -5.23e+09. What is the difference between the Expenses (in $) in Miscellaneous expenses in 2009 and the Expenses (in $) in Labor Taxes in 2011?
Give a very brief answer. 1.01e+11. What is the difference between the Expenses (in $) in Miscellaneous expenses in 2009 and the Expenses (in $) in Grants and Revenue in 2011?
Make the answer very short. 2.36e+1. What is the difference between the Expenses (in $) in Miscellaneous expenses in 2009 and the Expenses (in $) in Services in 2011?
Your answer should be compact. 5.09e+1. What is the difference between the Expenses (in $) of Labor Taxes in 2009 and the Expenses (in $) of Grants and Revenue in 2011?
Your answer should be compact. -9.01e+1. What is the difference between the Expenses (in $) in Labor Taxes in 2009 and the Expenses (in $) in Services in 2011?
Your answer should be very brief. -6.28e+1. What is the difference between the Expenses (in $) in Grants and Revenue in 2009 and the Expenses (in $) in Services in 2011?
Offer a terse response. -2.00e+1. What is the difference between the Expenses (in $) in Miscellaneous expenses in 2009 and the Expenses (in $) in Labor Taxes in 2012?
Provide a succinct answer. 9.50e+1. What is the difference between the Expenses (in $) of Miscellaneous expenses in 2009 and the Expenses (in $) of Grants and Revenue in 2012?
Offer a terse response. 6.06e+1. What is the difference between the Expenses (in $) of Miscellaneous expenses in 2009 and the Expenses (in $) of Services in 2012?
Offer a terse response. 2.27e+1. What is the difference between the Expenses (in $) of Labor Taxes in 2009 and the Expenses (in $) of Grants and Revenue in 2012?
Keep it short and to the point. -5.31e+1. What is the difference between the Expenses (in $) of Labor Taxes in 2009 and the Expenses (in $) of Services in 2012?
Ensure brevity in your answer.  -9.10e+1. What is the difference between the Expenses (in $) of Grants and Revenue in 2009 and the Expenses (in $) of Services in 2012?
Ensure brevity in your answer.  -4.83e+1. What is the difference between the Expenses (in $) of Miscellaneous expenses in 2010 and the Expenses (in $) of Labor Taxes in 2011?
Ensure brevity in your answer.  9.04e+1. What is the difference between the Expenses (in $) in Miscellaneous expenses in 2010 and the Expenses (in $) in Grants and Revenue in 2011?
Give a very brief answer. 1.28e+1. What is the difference between the Expenses (in $) in Miscellaneous expenses in 2010 and the Expenses (in $) in Services in 2011?
Your answer should be very brief. 4.01e+1. What is the difference between the Expenses (in $) in Labor Taxes in 2010 and the Expenses (in $) in Grants and Revenue in 2011?
Offer a very short reply. -8.53e+1. What is the difference between the Expenses (in $) of Labor Taxes in 2010 and the Expenses (in $) of Services in 2011?
Your response must be concise. -5.79e+1. What is the difference between the Expenses (in $) in Grants and Revenue in 2010 and the Expenses (in $) in Services in 2011?
Keep it short and to the point. -2.00e+09. What is the difference between the Expenses (in $) of Miscellaneous expenses in 2010 and the Expenses (in $) of Labor Taxes in 2012?
Offer a very short reply. 8.42e+1. What is the difference between the Expenses (in $) in Miscellaneous expenses in 2010 and the Expenses (in $) in Grants and Revenue in 2012?
Your answer should be compact. 4.97e+1. What is the difference between the Expenses (in $) in Miscellaneous expenses in 2010 and the Expenses (in $) in Services in 2012?
Offer a very short reply. 1.19e+1. What is the difference between the Expenses (in $) in Labor Taxes in 2010 and the Expenses (in $) in Grants and Revenue in 2012?
Offer a very short reply. -4.83e+1. What is the difference between the Expenses (in $) in Labor Taxes in 2010 and the Expenses (in $) in Services in 2012?
Make the answer very short. -8.61e+1. What is the difference between the Expenses (in $) in Grants and Revenue in 2010 and the Expenses (in $) in Services in 2012?
Your answer should be compact. -3.02e+1. What is the difference between the Expenses (in $) of Miscellaneous expenses in 2011 and the Expenses (in $) of Labor Taxes in 2012?
Give a very brief answer. 1.11e+11. What is the difference between the Expenses (in $) in Miscellaneous expenses in 2011 and the Expenses (in $) in Grants and Revenue in 2012?
Offer a terse response. 7.69e+1. What is the difference between the Expenses (in $) of Miscellaneous expenses in 2011 and the Expenses (in $) of Services in 2012?
Provide a succinct answer. 3.91e+1. What is the difference between the Expenses (in $) of Labor Taxes in 2011 and the Expenses (in $) of Grants and Revenue in 2012?
Give a very brief answer. -4.07e+1. What is the difference between the Expenses (in $) in Labor Taxes in 2011 and the Expenses (in $) in Services in 2012?
Make the answer very short. -7.85e+1. What is the difference between the Expenses (in $) of Grants and Revenue in 2011 and the Expenses (in $) of Services in 2012?
Provide a short and direct response. -8.87e+08. What is the average Expenses (in $) of Miscellaneous expenses per year?
Provide a succinct answer. 1.16e+11. What is the average Expenses (in $) in Labor Taxes per year?
Provide a succinct answer. 7.60e+1. What is the average Expenses (in $) of Grants and Revenue per year?
Ensure brevity in your answer.  1.05e+11. What is the average Expenses (in $) of Services per year?
Make the answer very short. 1.35e+11. In the year 2005, what is the difference between the Expenses (in $) in Miscellaneous expenses and Expenses (in $) in Labor Taxes?
Offer a terse response. -8.51e+1. In the year 2005, what is the difference between the Expenses (in $) in Miscellaneous expenses and Expenses (in $) in Grants and Revenue?
Your answer should be very brief. -5.94e+1. In the year 2005, what is the difference between the Expenses (in $) of Miscellaneous expenses and Expenses (in $) of Services?
Your response must be concise. -1.59e+11. In the year 2005, what is the difference between the Expenses (in $) of Labor Taxes and Expenses (in $) of Grants and Revenue?
Offer a very short reply. 2.56e+1. In the year 2005, what is the difference between the Expenses (in $) in Labor Taxes and Expenses (in $) in Services?
Your answer should be very brief. -7.37e+1. In the year 2005, what is the difference between the Expenses (in $) in Grants and Revenue and Expenses (in $) in Services?
Provide a succinct answer. -9.93e+1. In the year 2006, what is the difference between the Expenses (in $) in Miscellaneous expenses and Expenses (in $) in Labor Taxes?
Your response must be concise. -7.96e+1. In the year 2006, what is the difference between the Expenses (in $) in Miscellaneous expenses and Expenses (in $) in Grants and Revenue?
Your answer should be very brief. -5.68e+1. In the year 2006, what is the difference between the Expenses (in $) in Miscellaneous expenses and Expenses (in $) in Services?
Make the answer very short. -1.37e+11. In the year 2006, what is the difference between the Expenses (in $) in Labor Taxes and Expenses (in $) in Grants and Revenue?
Provide a succinct answer. 2.28e+1. In the year 2006, what is the difference between the Expenses (in $) of Labor Taxes and Expenses (in $) of Services?
Your response must be concise. -5.71e+1. In the year 2006, what is the difference between the Expenses (in $) of Grants and Revenue and Expenses (in $) of Services?
Your answer should be very brief. -8.00e+1. In the year 2007, what is the difference between the Expenses (in $) of Miscellaneous expenses and Expenses (in $) of Labor Taxes?
Give a very brief answer. -3.92e+1. In the year 2007, what is the difference between the Expenses (in $) of Miscellaneous expenses and Expenses (in $) of Grants and Revenue?
Give a very brief answer. -7.69e+1. In the year 2007, what is the difference between the Expenses (in $) in Miscellaneous expenses and Expenses (in $) in Services?
Provide a short and direct response. -1.64e+11. In the year 2007, what is the difference between the Expenses (in $) of Labor Taxes and Expenses (in $) of Grants and Revenue?
Provide a succinct answer. -3.76e+1. In the year 2007, what is the difference between the Expenses (in $) of Labor Taxes and Expenses (in $) of Services?
Keep it short and to the point. -1.25e+11. In the year 2007, what is the difference between the Expenses (in $) of Grants and Revenue and Expenses (in $) of Services?
Give a very brief answer. -8.71e+1. In the year 2008, what is the difference between the Expenses (in $) of Miscellaneous expenses and Expenses (in $) of Labor Taxes?
Offer a terse response. 8.96e+1. In the year 2008, what is the difference between the Expenses (in $) in Miscellaneous expenses and Expenses (in $) in Grants and Revenue?
Keep it short and to the point. 6.11e+1. In the year 2008, what is the difference between the Expenses (in $) of Miscellaneous expenses and Expenses (in $) of Services?
Offer a very short reply. 7.96e+1. In the year 2008, what is the difference between the Expenses (in $) of Labor Taxes and Expenses (in $) of Grants and Revenue?
Your answer should be very brief. -2.85e+1. In the year 2008, what is the difference between the Expenses (in $) of Labor Taxes and Expenses (in $) of Services?
Provide a succinct answer. -9.99e+09. In the year 2008, what is the difference between the Expenses (in $) in Grants and Revenue and Expenses (in $) in Services?
Offer a terse response. 1.85e+1. In the year 2009, what is the difference between the Expenses (in $) in Miscellaneous expenses and Expenses (in $) in Labor Taxes?
Make the answer very short. 1.14e+11. In the year 2009, what is the difference between the Expenses (in $) of Miscellaneous expenses and Expenses (in $) of Grants and Revenue?
Make the answer very short. 7.10e+1. In the year 2009, what is the difference between the Expenses (in $) in Miscellaneous expenses and Expenses (in $) in Services?
Keep it short and to the point. 7.67e+1. In the year 2009, what is the difference between the Expenses (in $) in Labor Taxes and Expenses (in $) in Grants and Revenue?
Offer a very short reply. -4.27e+1. In the year 2009, what is the difference between the Expenses (in $) in Labor Taxes and Expenses (in $) in Services?
Your answer should be very brief. -3.71e+1. In the year 2009, what is the difference between the Expenses (in $) of Grants and Revenue and Expenses (in $) of Services?
Your answer should be compact. 5.66e+09. In the year 2010, what is the difference between the Expenses (in $) of Miscellaneous expenses and Expenses (in $) of Labor Taxes?
Ensure brevity in your answer.  9.81e+1. In the year 2010, what is the difference between the Expenses (in $) in Miscellaneous expenses and Expenses (in $) in Grants and Revenue?
Your answer should be very brief. 4.21e+1. In the year 2010, what is the difference between the Expenses (in $) in Miscellaneous expenses and Expenses (in $) in Services?
Make the answer very short. 5.49e+1. In the year 2010, what is the difference between the Expenses (in $) in Labor Taxes and Expenses (in $) in Grants and Revenue?
Provide a short and direct response. -5.59e+1. In the year 2010, what is the difference between the Expenses (in $) of Labor Taxes and Expenses (in $) of Services?
Your answer should be very brief. -4.31e+1. In the year 2010, what is the difference between the Expenses (in $) of Grants and Revenue and Expenses (in $) of Services?
Offer a terse response. 1.28e+1. In the year 2011, what is the difference between the Expenses (in $) in Miscellaneous expenses and Expenses (in $) in Labor Taxes?
Offer a very short reply. 1.18e+11. In the year 2011, what is the difference between the Expenses (in $) in Miscellaneous expenses and Expenses (in $) in Grants and Revenue?
Offer a very short reply. 3.99e+1. In the year 2011, what is the difference between the Expenses (in $) of Miscellaneous expenses and Expenses (in $) of Services?
Ensure brevity in your answer.  6.73e+1. In the year 2011, what is the difference between the Expenses (in $) of Labor Taxes and Expenses (in $) of Grants and Revenue?
Offer a terse response. -7.76e+1. In the year 2011, what is the difference between the Expenses (in $) of Labor Taxes and Expenses (in $) of Services?
Provide a succinct answer. -5.03e+1. In the year 2011, what is the difference between the Expenses (in $) of Grants and Revenue and Expenses (in $) of Services?
Offer a very short reply. 2.73e+1. In the year 2012, what is the difference between the Expenses (in $) in Miscellaneous expenses and Expenses (in $) in Labor Taxes?
Provide a short and direct response. 1.03e+11. In the year 2012, what is the difference between the Expenses (in $) in Miscellaneous expenses and Expenses (in $) in Grants and Revenue?
Offer a terse response. 6.85e+1. In the year 2012, what is the difference between the Expenses (in $) in Miscellaneous expenses and Expenses (in $) in Services?
Offer a very short reply. 3.07e+1. In the year 2012, what is the difference between the Expenses (in $) in Labor Taxes and Expenses (in $) in Grants and Revenue?
Provide a short and direct response. -3.44e+1. In the year 2012, what is the difference between the Expenses (in $) in Labor Taxes and Expenses (in $) in Services?
Make the answer very short. -7.23e+1. In the year 2012, what is the difference between the Expenses (in $) of Grants and Revenue and Expenses (in $) of Services?
Ensure brevity in your answer.  -3.78e+1. What is the ratio of the Expenses (in $) in Miscellaneous expenses in 2005 to that in 2006?
Make the answer very short. 0.15. What is the ratio of the Expenses (in $) of Labor Taxes in 2005 to that in 2006?
Provide a short and direct response. 0.87. What is the ratio of the Expenses (in $) in Grants and Revenue in 2005 to that in 2006?
Offer a very short reply. 0.8. What is the ratio of the Expenses (in $) in Services in 2005 to that in 2006?
Ensure brevity in your answer.  1.02. What is the ratio of the Expenses (in $) in Miscellaneous expenses in 2005 to that in 2007?
Ensure brevity in your answer.  0.11. What is the ratio of the Expenses (in $) of Labor Taxes in 2005 to that in 2007?
Give a very brief answer. 1.27. What is the ratio of the Expenses (in $) of Grants and Revenue in 2005 to that in 2007?
Provide a succinct answer. 0.58. What is the ratio of the Expenses (in $) of Services in 2005 to that in 2007?
Your response must be concise. 0.83. What is the ratio of the Expenses (in $) of Miscellaneous expenses in 2005 to that in 2008?
Ensure brevity in your answer.  0.02. What is the ratio of the Expenses (in $) of Labor Taxes in 2005 to that in 2008?
Make the answer very short. 1.11. What is the ratio of the Expenses (in $) in Grants and Revenue in 2005 to that in 2008?
Offer a terse response. 0.58. What is the ratio of the Expenses (in $) in Services in 2005 to that in 2008?
Give a very brief answer. 1.81. What is the ratio of the Expenses (in $) of Miscellaneous expenses in 2005 to that in 2009?
Give a very brief answer. 0.02. What is the ratio of the Expenses (in $) in Labor Taxes in 2005 to that in 2009?
Ensure brevity in your answer.  1.52. What is the ratio of the Expenses (in $) in Grants and Revenue in 2005 to that in 2009?
Your answer should be very brief. 0.62. What is the ratio of the Expenses (in $) in Services in 2005 to that in 2009?
Offer a terse response. 1.7. What is the ratio of the Expenses (in $) of Miscellaneous expenses in 2005 to that in 2010?
Give a very brief answer. 0.02. What is the ratio of the Expenses (in $) of Labor Taxes in 2005 to that in 2010?
Provide a short and direct response. 1.4. What is the ratio of the Expenses (in $) in Grants and Revenue in 2005 to that in 2010?
Your answer should be very brief. 0.53. What is the ratio of the Expenses (in $) of Services in 2005 to that in 2010?
Your response must be concise. 1.53. What is the ratio of the Expenses (in $) of Miscellaneous expenses in 2005 to that in 2011?
Provide a short and direct response. 0.02. What is the ratio of the Expenses (in $) of Labor Taxes in 2005 to that in 2011?
Offer a very short reply. 1.25. What is the ratio of the Expenses (in $) in Grants and Revenue in 2005 to that in 2011?
Ensure brevity in your answer.  0.42. What is the ratio of the Expenses (in $) in Services in 2005 to that in 2011?
Give a very brief answer. 1.34. What is the ratio of the Expenses (in $) of Miscellaneous expenses in 2005 to that in 2012?
Keep it short and to the point. 0.02. What is the ratio of the Expenses (in $) in Labor Taxes in 2005 to that in 2012?
Make the answer very short. 1.15. What is the ratio of the Expenses (in $) of Grants and Revenue in 2005 to that in 2012?
Offer a terse response. 0.56. What is the ratio of the Expenses (in $) in Services in 2005 to that in 2012?
Your response must be concise. 1.09. What is the ratio of the Expenses (in $) of Miscellaneous expenses in 2006 to that in 2007?
Keep it short and to the point. 0.71. What is the ratio of the Expenses (in $) in Labor Taxes in 2006 to that in 2007?
Provide a short and direct response. 1.45. What is the ratio of the Expenses (in $) in Grants and Revenue in 2006 to that in 2007?
Your answer should be very brief. 0.73. What is the ratio of the Expenses (in $) of Services in 2006 to that in 2007?
Provide a succinct answer. 0.81. What is the ratio of the Expenses (in $) in Miscellaneous expenses in 2006 to that in 2008?
Ensure brevity in your answer.  0.13. What is the ratio of the Expenses (in $) of Labor Taxes in 2006 to that in 2008?
Provide a short and direct response. 1.27. What is the ratio of the Expenses (in $) of Grants and Revenue in 2006 to that in 2008?
Ensure brevity in your answer.  0.72. What is the ratio of the Expenses (in $) in Services in 2006 to that in 2008?
Provide a succinct answer. 1.77. What is the ratio of the Expenses (in $) of Miscellaneous expenses in 2006 to that in 2009?
Your answer should be very brief. 0.13. What is the ratio of the Expenses (in $) of Labor Taxes in 2006 to that in 2009?
Provide a short and direct response. 1.74. What is the ratio of the Expenses (in $) in Grants and Revenue in 2006 to that in 2009?
Your answer should be compact. 0.78. What is the ratio of the Expenses (in $) in Services in 2006 to that in 2009?
Your response must be concise. 1.66. What is the ratio of the Expenses (in $) in Miscellaneous expenses in 2006 to that in 2010?
Your answer should be very brief. 0.13. What is the ratio of the Expenses (in $) in Labor Taxes in 2006 to that in 2010?
Provide a short and direct response. 1.6. What is the ratio of the Expenses (in $) of Grants and Revenue in 2006 to that in 2010?
Your answer should be very brief. 0.66. What is the ratio of the Expenses (in $) in Services in 2006 to that in 2010?
Offer a very short reply. 1.49. What is the ratio of the Expenses (in $) in Miscellaneous expenses in 2006 to that in 2011?
Provide a succinct answer. 0.11. What is the ratio of the Expenses (in $) of Labor Taxes in 2006 to that in 2011?
Your answer should be very brief. 1.43. What is the ratio of the Expenses (in $) in Grants and Revenue in 2006 to that in 2011?
Your answer should be compact. 0.53. What is the ratio of the Expenses (in $) in Services in 2006 to that in 2011?
Make the answer very short. 1.31. What is the ratio of the Expenses (in $) of Miscellaneous expenses in 2006 to that in 2012?
Provide a short and direct response. 0.12. What is the ratio of the Expenses (in $) of Labor Taxes in 2006 to that in 2012?
Provide a short and direct response. 1.32. What is the ratio of the Expenses (in $) in Grants and Revenue in 2006 to that in 2012?
Give a very brief answer. 0.7. What is the ratio of the Expenses (in $) of Services in 2006 to that in 2012?
Make the answer very short. 1.06. What is the ratio of the Expenses (in $) of Miscellaneous expenses in 2007 to that in 2008?
Your answer should be compact. 0.18. What is the ratio of the Expenses (in $) in Labor Taxes in 2007 to that in 2008?
Your response must be concise. 0.87. What is the ratio of the Expenses (in $) in Services in 2007 to that in 2008?
Offer a terse response. 2.17. What is the ratio of the Expenses (in $) of Miscellaneous expenses in 2007 to that in 2009?
Your answer should be compact. 0.18. What is the ratio of the Expenses (in $) of Labor Taxes in 2007 to that in 2009?
Offer a terse response. 1.19. What is the ratio of the Expenses (in $) in Grants and Revenue in 2007 to that in 2009?
Your answer should be very brief. 1.06. What is the ratio of the Expenses (in $) of Services in 2007 to that in 2009?
Give a very brief answer. 2.04. What is the ratio of the Expenses (in $) of Miscellaneous expenses in 2007 to that in 2010?
Ensure brevity in your answer.  0.19. What is the ratio of the Expenses (in $) in Labor Taxes in 2007 to that in 2010?
Ensure brevity in your answer.  1.1. What is the ratio of the Expenses (in $) in Grants and Revenue in 2007 to that in 2010?
Offer a very short reply. 0.9. What is the ratio of the Expenses (in $) of Services in 2007 to that in 2010?
Ensure brevity in your answer.  1.83. What is the ratio of the Expenses (in $) in Miscellaneous expenses in 2007 to that in 2011?
Keep it short and to the point. 0.16. What is the ratio of the Expenses (in $) of Labor Taxes in 2007 to that in 2011?
Ensure brevity in your answer.  0.98. What is the ratio of the Expenses (in $) of Grants and Revenue in 2007 to that in 2011?
Make the answer very short. 0.72. What is the ratio of the Expenses (in $) in Services in 2007 to that in 2011?
Offer a terse response. 1.61. What is the ratio of the Expenses (in $) of Miscellaneous expenses in 2007 to that in 2012?
Offer a terse response. 0.17. What is the ratio of the Expenses (in $) of Labor Taxes in 2007 to that in 2012?
Offer a very short reply. 0.9. What is the ratio of the Expenses (in $) in Grants and Revenue in 2007 to that in 2012?
Provide a succinct answer. 0.96. What is the ratio of the Expenses (in $) in Services in 2007 to that in 2012?
Offer a terse response. 1.3. What is the ratio of the Expenses (in $) in Miscellaneous expenses in 2008 to that in 2009?
Keep it short and to the point. 0.98. What is the ratio of the Expenses (in $) in Labor Taxes in 2008 to that in 2009?
Provide a short and direct response. 1.37. What is the ratio of the Expenses (in $) in Grants and Revenue in 2008 to that in 2009?
Offer a terse response. 1.07. What is the ratio of the Expenses (in $) in Services in 2008 to that in 2009?
Your response must be concise. 0.94. What is the ratio of the Expenses (in $) in Miscellaneous expenses in 2008 to that in 2010?
Offer a very short reply. 1.05. What is the ratio of the Expenses (in $) in Labor Taxes in 2008 to that in 2010?
Offer a very short reply. 1.26. What is the ratio of the Expenses (in $) of Grants and Revenue in 2008 to that in 2010?
Offer a very short reply. 0.91. What is the ratio of the Expenses (in $) in Services in 2008 to that in 2010?
Your answer should be compact. 0.84. What is the ratio of the Expenses (in $) in Miscellaneous expenses in 2008 to that in 2011?
Make the answer very short. 0.9. What is the ratio of the Expenses (in $) in Labor Taxes in 2008 to that in 2011?
Offer a terse response. 1.13. What is the ratio of the Expenses (in $) of Grants and Revenue in 2008 to that in 2011?
Your response must be concise. 0.73. What is the ratio of the Expenses (in $) in Services in 2008 to that in 2011?
Your answer should be very brief. 0.74. What is the ratio of the Expenses (in $) in Miscellaneous expenses in 2008 to that in 2012?
Your answer should be compact. 0.94. What is the ratio of the Expenses (in $) in Labor Taxes in 2008 to that in 2012?
Give a very brief answer. 1.03. What is the ratio of the Expenses (in $) of Grants and Revenue in 2008 to that in 2012?
Give a very brief answer. 0.97. What is the ratio of the Expenses (in $) in Services in 2008 to that in 2012?
Provide a succinct answer. 0.6. What is the ratio of the Expenses (in $) of Miscellaneous expenses in 2009 to that in 2010?
Make the answer very short. 1.07. What is the ratio of the Expenses (in $) of Labor Taxes in 2009 to that in 2010?
Your answer should be compact. 0.92. What is the ratio of the Expenses (in $) of Grants and Revenue in 2009 to that in 2010?
Offer a very short reply. 0.85. What is the ratio of the Expenses (in $) of Services in 2009 to that in 2010?
Give a very brief answer. 0.9. What is the ratio of the Expenses (in $) of Miscellaneous expenses in 2009 to that in 2011?
Your answer should be very brief. 0.91. What is the ratio of the Expenses (in $) in Labor Taxes in 2009 to that in 2011?
Ensure brevity in your answer.  0.82. What is the ratio of the Expenses (in $) of Grants and Revenue in 2009 to that in 2011?
Ensure brevity in your answer.  0.68. What is the ratio of the Expenses (in $) in Services in 2009 to that in 2011?
Give a very brief answer. 0.79. What is the ratio of the Expenses (in $) in Miscellaneous expenses in 2009 to that in 2012?
Offer a terse response. 0.96. What is the ratio of the Expenses (in $) in Labor Taxes in 2009 to that in 2012?
Keep it short and to the point. 0.76. What is the ratio of the Expenses (in $) of Grants and Revenue in 2009 to that in 2012?
Provide a short and direct response. 0.91. What is the ratio of the Expenses (in $) in Services in 2009 to that in 2012?
Provide a succinct answer. 0.64. What is the ratio of the Expenses (in $) in Miscellaneous expenses in 2010 to that in 2011?
Offer a very short reply. 0.86. What is the ratio of the Expenses (in $) of Labor Taxes in 2010 to that in 2011?
Keep it short and to the point. 0.89. What is the ratio of the Expenses (in $) in Grants and Revenue in 2010 to that in 2011?
Your answer should be compact. 0.8. What is the ratio of the Expenses (in $) in Services in 2010 to that in 2011?
Your response must be concise. 0.88. What is the ratio of the Expenses (in $) in Miscellaneous expenses in 2010 to that in 2012?
Offer a terse response. 0.9. What is the ratio of the Expenses (in $) in Labor Taxes in 2010 to that in 2012?
Offer a terse response. 0.82. What is the ratio of the Expenses (in $) of Grants and Revenue in 2010 to that in 2012?
Offer a terse response. 1.07. What is the ratio of the Expenses (in $) in Services in 2010 to that in 2012?
Offer a very short reply. 0.71. What is the ratio of the Expenses (in $) of Miscellaneous expenses in 2011 to that in 2012?
Keep it short and to the point. 1.05. What is the ratio of the Expenses (in $) of Labor Taxes in 2011 to that in 2012?
Your response must be concise. 0.92. What is the ratio of the Expenses (in $) in Grants and Revenue in 2011 to that in 2012?
Your answer should be compact. 1.33. What is the ratio of the Expenses (in $) in Services in 2011 to that in 2012?
Provide a short and direct response. 0.81. What is the difference between the highest and the second highest Expenses (in $) in Miscellaneous expenses?
Ensure brevity in your answer.  8.36e+09. What is the difference between the highest and the second highest Expenses (in $) of Labor Taxes?
Offer a terse response. 1.29e+1. What is the difference between the highest and the second highest Expenses (in $) in Grants and Revenue?
Ensure brevity in your answer.  2.93e+1. What is the difference between the highest and the second highest Expenses (in $) of Services?
Your answer should be very brief. 3.23e+1. What is the difference between the highest and the lowest Expenses (in $) in Miscellaneous expenses?
Offer a terse response. 1.85e+11. What is the difference between the highest and the lowest Expenses (in $) in Labor Taxes?
Keep it short and to the point. 4.30e+1. What is the difference between the highest and the lowest Expenses (in $) of Grants and Revenue?
Provide a short and direct response. 8.56e+1. What is the difference between the highest and the lowest Expenses (in $) of Services?
Provide a short and direct response. 1.05e+11. 